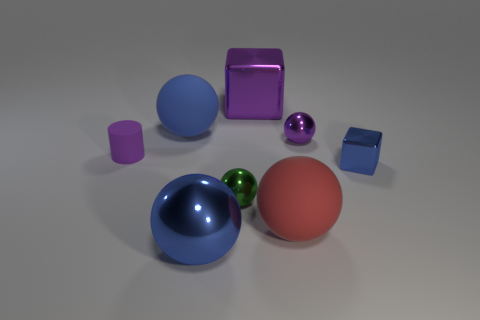Add 1 purple cylinders. How many objects exist? 9 Subtract all green shiny spheres. How many spheres are left? 4 Subtract all blue blocks. How many blue balls are left? 2 Subtract 4 spheres. How many spheres are left? 1 Subtract all blocks. How many objects are left? 6 Subtract all green balls. How many balls are left? 4 Add 2 tiny green shiny objects. How many tiny green shiny objects are left? 3 Add 5 blue matte spheres. How many blue matte spheres exist? 6 Subtract 1 purple blocks. How many objects are left? 7 Subtract all blue blocks. Subtract all gray balls. How many blocks are left? 1 